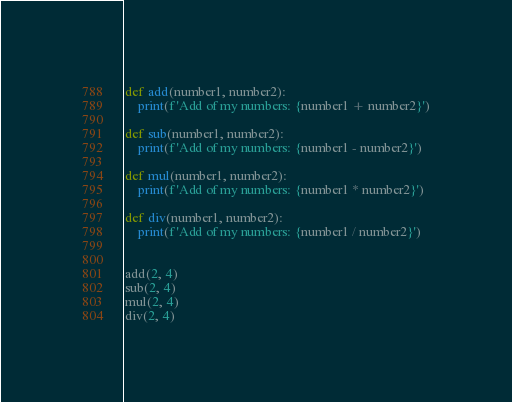<code> <loc_0><loc_0><loc_500><loc_500><_Python_>def add(number1, number2):
    print(f'Add of my numbers: {number1 + number2}')

def sub(number1, number2):
    print(f'Add of my numbers: {number1 - number2}')

def mul(number1, number2):
    print(f'Add of my numbers: {number1 * number2}')

def div(number1, number2):
    print(f'Add of my numbers: {number1 / number2}')


add(2, 4)
sub(2, 4)
mul(2, 4)
div(2, 4)</code> 